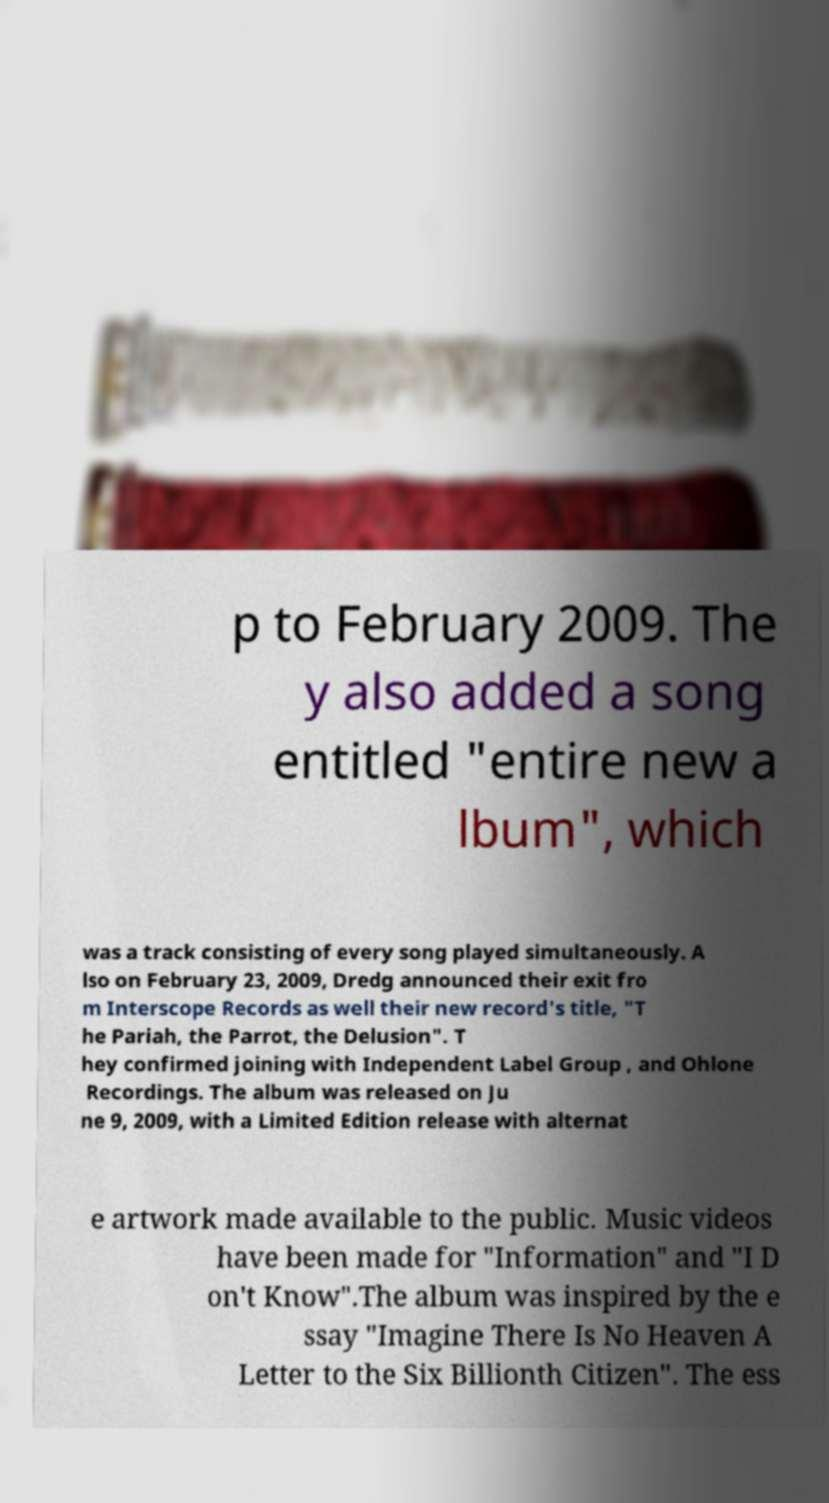Could you extract and type out the text from this image? p to February 2009. The y also added a song entitled "entire new a lbum", which was a track consisting of every song played simultaneously. A lso on February 23, 2009, Dredg announced their exit fro m Interscope Records as well their new record's title, "T he Pariah, the Parrot, the Delusion". T hey confirmed joining with Independent Label Group , and Ohlone Recordings. The album was released on Ju ne 9, 2009, with a Limited Edition release with alternat e artwork made available to the public. Music videos have been made for "Information" and "I D on't Know".The album was inspired by the e ssay "Imagine There Is No Heaven A Letter to the Six Billionth Citizen". The ess 